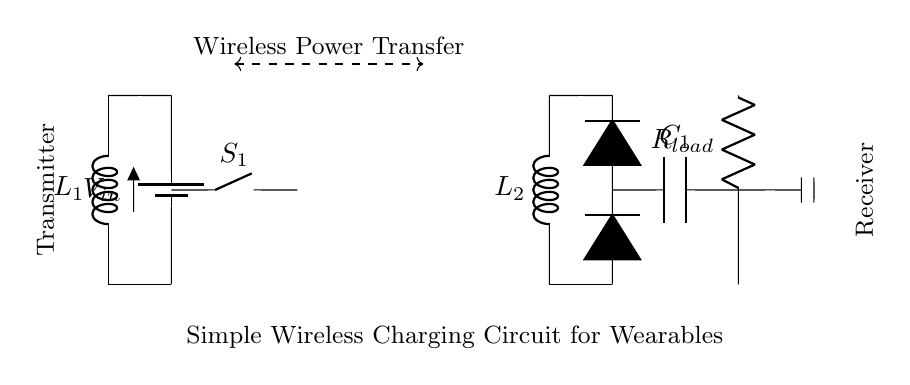What is the type of power source used in this circuit? The circuit uses a battery as its power source, indicated by the icon labeled as V_in.
Answer: battery How many coils are present in this wireless charging circuit? There are two coils: a transmitter coil labeled L1 and a receiver coil labeled L2.
Answer: two What is the function of the switch S1 in this circuit? Switch S1 acts as a control mechanism to either allow or interrupt the flow of electricity from the battery to the transmitter coil, thus enabling or disabling the wireless charging.
Answer: control Which component is responsible for rectifying AC to DC? The component used for rectification in this circuit is a diode, represented by the symbol D*.
Answer: diode What is the role of capacitor C1 in this circuit? Capacitor C1 smooths out the rectified voltage after the wireless power transfer, stabilizing the output to the load.
Answer: smoothing What type of circuit is this? This circuit is a wireless charging circuit designed for wearables, highlighted by the wireless power transfer and components associated with both transmission and reception.
Answer: wireless charging circuit How does energy transfer occur between the transmitter and receiver coils? Energy transfer occurs inductively through the magnetic field generated by the alternating current in the transmitter coil, which induces a current in the receiver coil, enabling the charging process.
Answer: inductively 